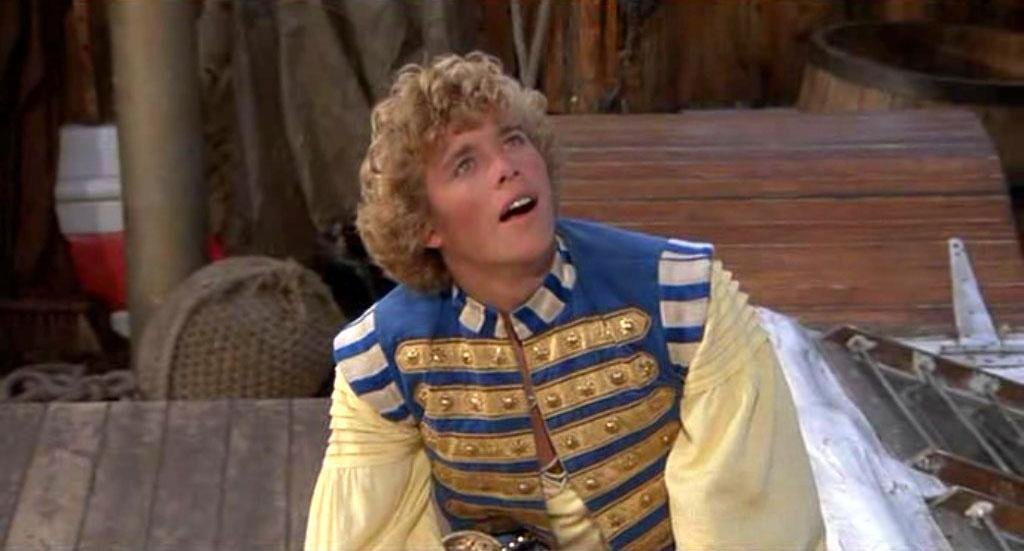What is the main subject in the image? There is a person in the image. What object can be seen near the person? There is a table in the image. What other objects are present in the image? There is a rope, a pole, stairs, and a drum in the image. How many centimeters long is the quill used by the person in the image? There is no quill present in the image, so it is not possible to determine its length. 